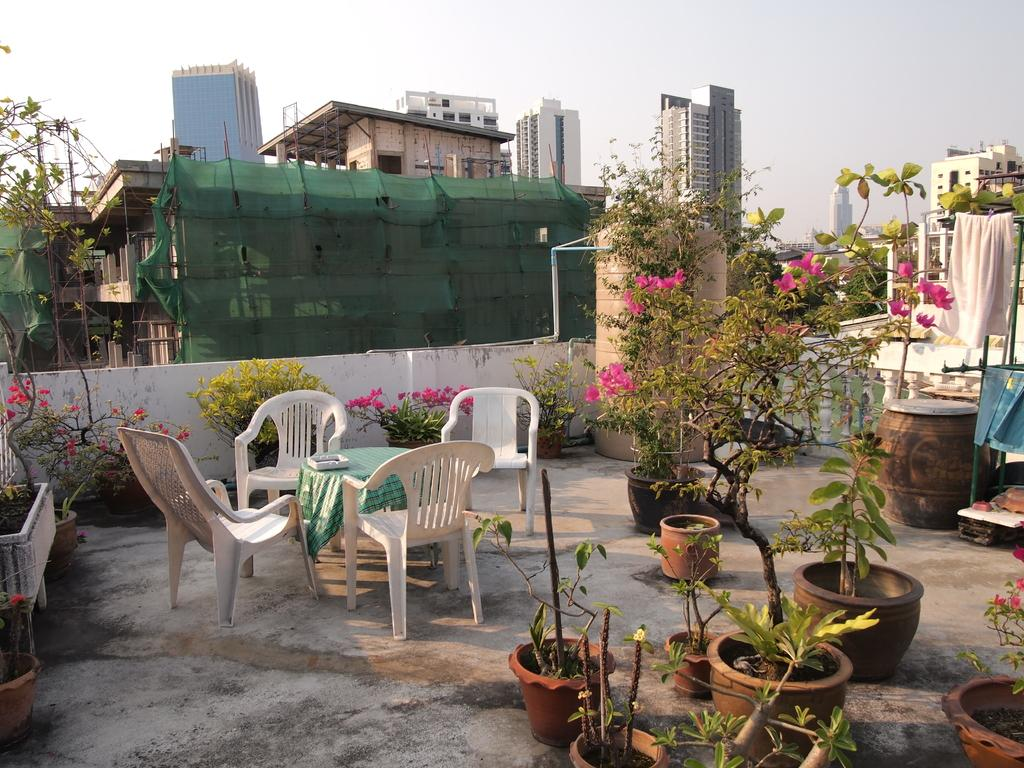What type of furniture is on the building in the image? There is a table and chairs on the building in the image. What kind of plants are visible in the image? There are water plants in the image. What is hanging on a pole in the image? There is a cloth hanging on a pole in the image. What can be seen in the distance in the image? There are buildings in the background of the image. What is visible above the buildings in the image? The sky is visible in the background of the image. What color is the bead that is hanging from the chalk in the image? There is no bead or chalk present in the image. How many underwear items are visible on the table in the image? There are no underwear items visible in the image. 